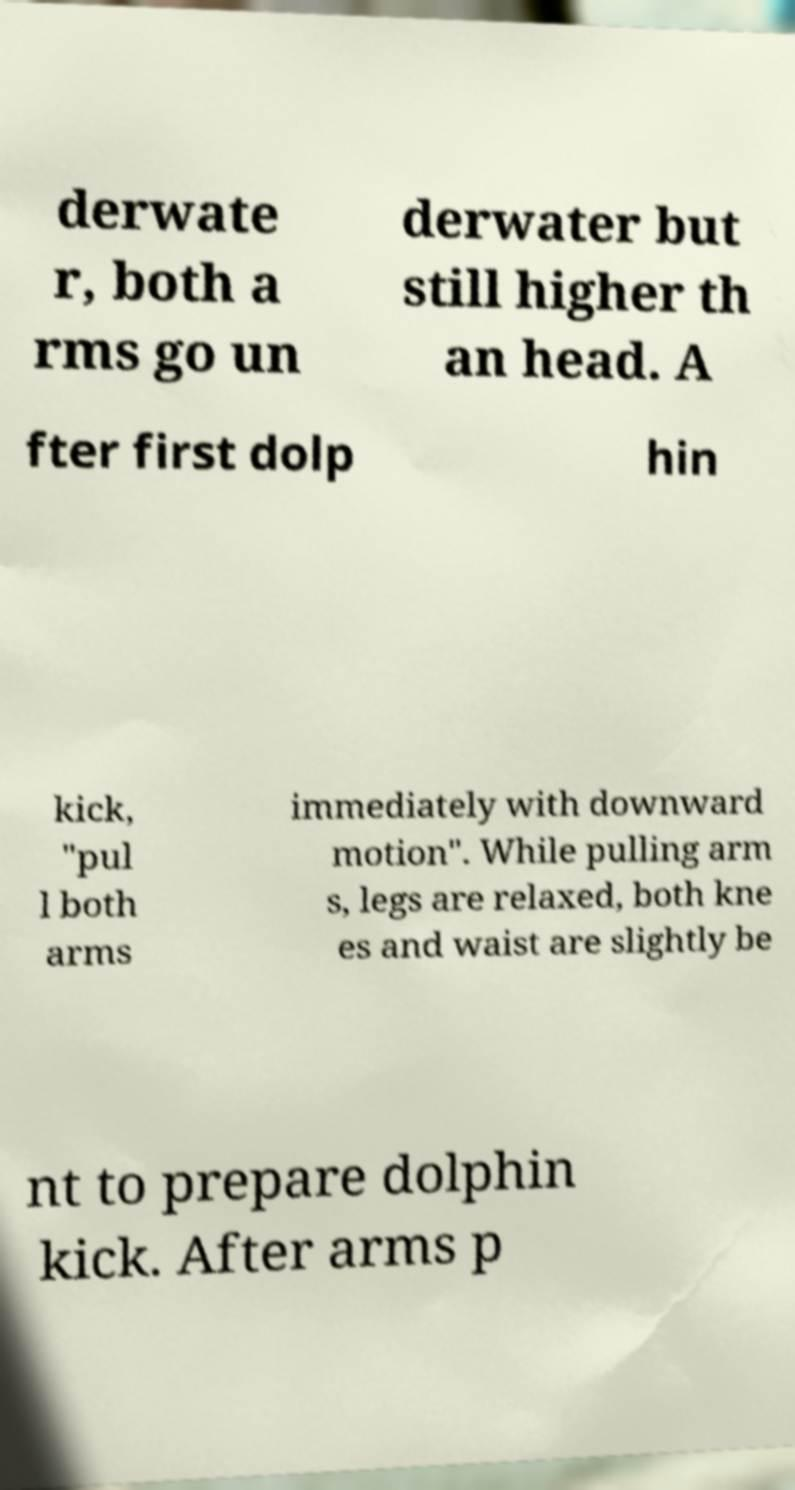Can you read and provide the text displayed in the image?This photo seems to have some interesting text. Can you extract and type it out for me? derwate r, both a rms go un derwater but still higher th an head. A fter first dolp hin kick, "pul l both arms immediately with downward motion". While pulling arm s, legs are relaxed, both kne es and waist are slightly be nt to prepare dolphin kick. After arms p 